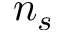Convert formula to latex. <formula><loc_0><loc_0><loc_500><loc_500>n _ { s }</formula> 